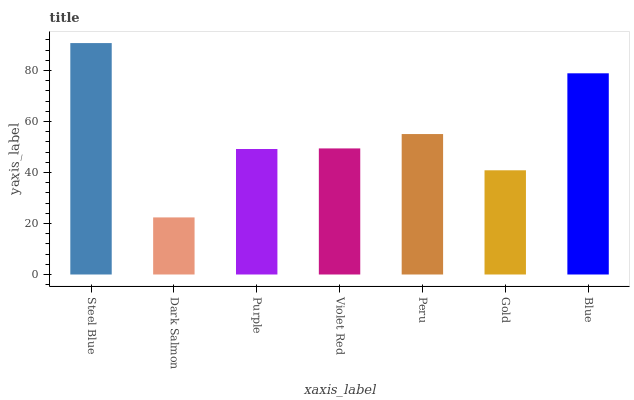Is Purple the minimum?
Answer yes or no. No. Is Purple the maximum?
Answer yes or no. No. Is Purple greater than Dark Salmon?
Answer yes or no. Yes. Is Dark Salmon less than Purple?
Answer yes or no. Yes. Is Dark Salmon greater than Purple?
Answer yes or no. No. Is Purple less than Dark Salmon?
Answer yes or no. No. Is Violet Red the high median?
Answer yes or no. Yes. Is Violet Red the low median?
Answer yes or no. Yes. Is Blue the high median?
Answer yes or no. No. Is Blue the low median?
Answer yes or no. No. 